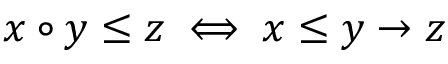<formula> <loc_0><loc_0><loc_500><loc_500>x \circ y \leq z \iff x \leq y \to z</formula> 